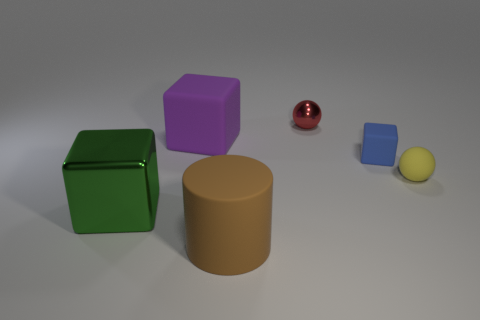Is the blue rubber cube the same size as the green metal object?
Make the answer very short. No. Are there more small matte spheres than large metal cylinders?
Offer a terse response. Yes. How many other things are there of the same color as the tiny metal thing?
Keep it short and to the point. 0. What number of things are large cyan cubes or small yellow things?
Your answer should be compact. 1. Does the rubber thing right of the blue block have the same shape as the big green metallic object?
Offer a very short reply. No. What color is the cube on the right side of the object in front of the green thing?
Offer a very short reply. Blue. Is the number of green shiny objects less than the number of small things?
Offer a very short reply. Yes. Are there any large cylinders that have the same material as the tiny blue thing?
Make the answer very short. Yes. There is a purple matte thing; is its shape the same as the shiny thing that is to the left of the tiny red object?
Your response must be concise. Yes. Are there any large brown cylinders behind the brown rubber object?
Your answer should be very brief. No. 